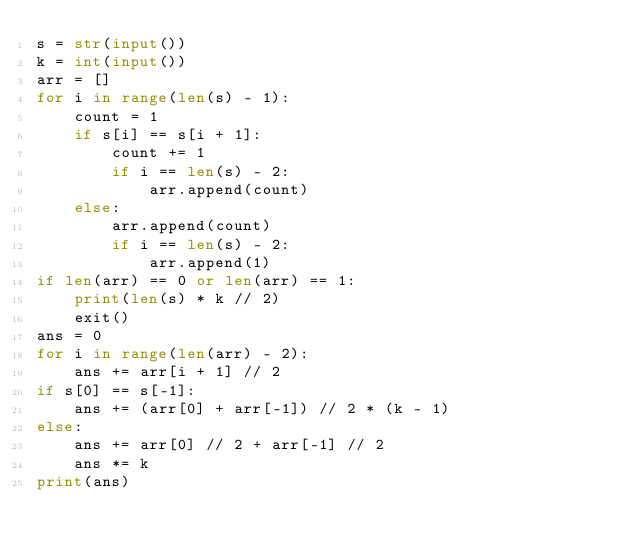Convert code to text. <code><loc_0><loc_0><loc_500><loc_500><_Python_>s = str(input())
k = int(input())
arr = []
for i in range(len(s) - 1):
    count = 1
    if s[i] == s[i + 1]:
        count += 1
        if i == len(s) - 2:
            arr.append(count)
    else:
        arr.append(count)
        if i == len(s) - 2:
            arr.append(1)
if len(arr) == 0 or len(arr) == 1:
    print(len(s) * k // 2)
    exit()
ans = 0
for i in range(len(arr) - 2):
    ans += arr[i + 1] // 2
if s[0] == s[-1]:
    ans += (arr[0] + arr[-1]) // 2 * (k - 1)
else:
    ans += arr[0] // 2 + arr[-1] // 2
    ans *= k
print(ans)</code> 